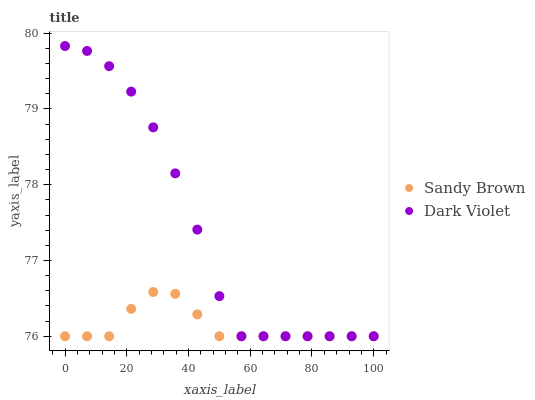Does Sandy Brown have the minimum area under the curve?
Answer yes or no. Yes. Does Dark Violet have the maximum area under the curve?
Answer yes or no. Yes. Does Dark Violet have the minimum area under the curve?
Answer yes or no. No. Is Sandy Brown the smoothest?
Answer yes or no. Yes. Is Dark Violet the roughest?
Answer yes or no. Yes. Is Dark Violet the smoothest?
Answer yes or no. No. Does Sandy Brown have the lowest value?
Answer yes or no. Yes. Does Dark Violet have the highest value?
Answer yes or no. Yes. Does Sandy Brown intersect Dark Violet?
Answer yes or no. Yes. Is Sandy Brown less than Dark Violet?
Answer yes or no. No. Is Sandy Brown greater than Dark Violet?
Answer yes or no. No. 